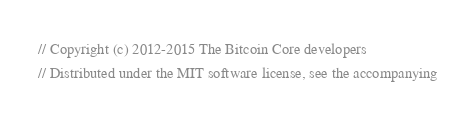Convert code to text. <code><loc_0><loc_0><loc_500><loc_500><_C++_>// Copyright (c) 2012-2015 The Bitcoin Core developers
// Distributed under the MIT software license, see the accompanying</code> 